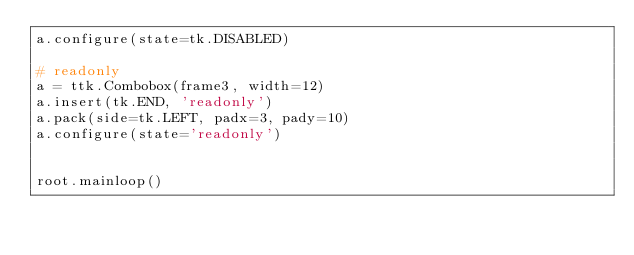<code> <loc_0><loc_0><loc_500><loc_500><_Python_>a.configure(state=tk.DISABLED)

# readonly
a = ttk.Combobox(frame3, width=12)
a.insert(tk.END, 'readonly')
a.pack(side=tk.LEFT, padx=3, pady=10)
a.configure(state='readonly')


root.mainloop()
</code> 